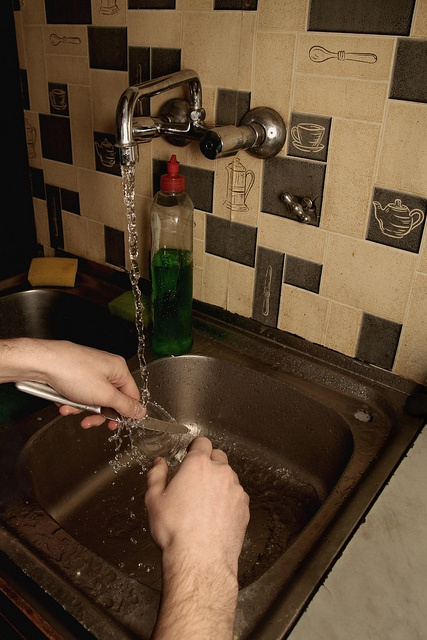Describe the objects in this image and their specific colors. I can see sink in black, maroon, and gray tones, people in black, tan, and gray tones, bottle in black, gray, and maroon tones, and knife in black, maroon, and gray tones in this image. 